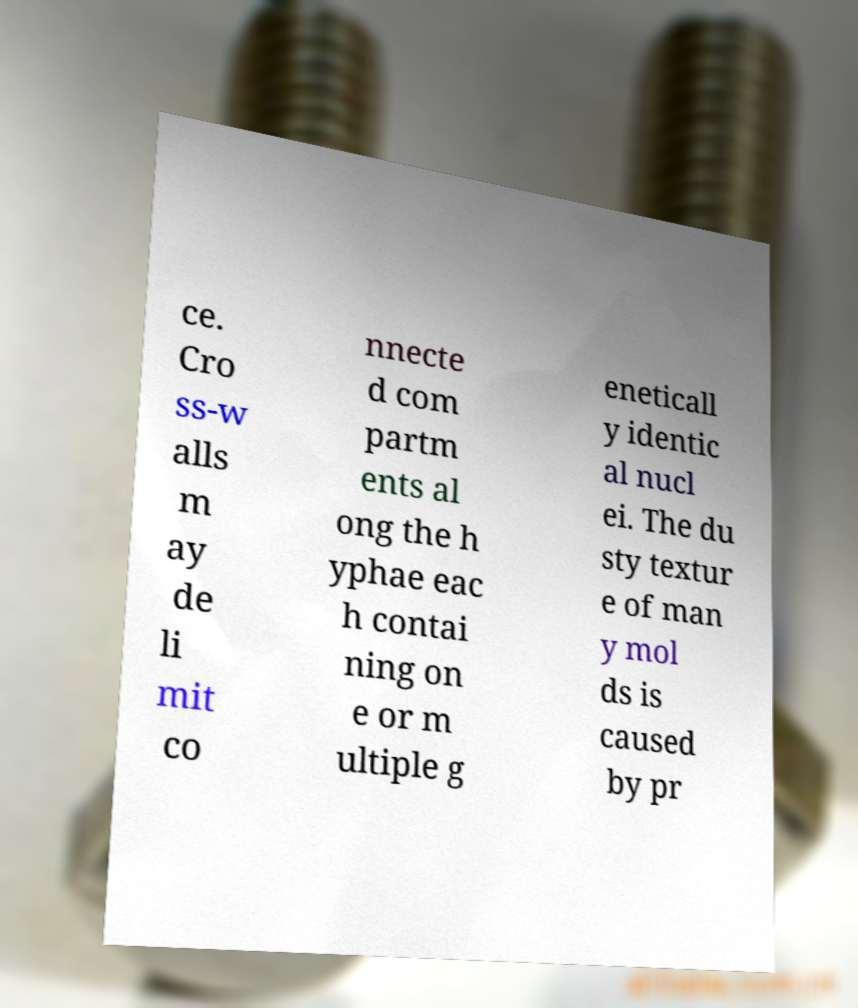Could you assist in decoding the text presented in this image and type it out clearly? ce. Cro ss-w alls m ay de li mit co nnecte d com partm ents al ong the h yphae eac h contai ning on e or m ultiple g eneticall y identic al nucl ei. The du sty textur e of man y mol ds is caused by pr 